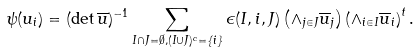<formula> <loc_0><loc_0><loc_500><loc_500>\psi ( u _ { i } ) = ( \det \overline { u } ) ^ { - 1 } \sum _ { I \cap J = \emptyset , ( I \cup J ) ^ { c } = \{ i \} } \epsilon ( I , i , J ) \left ( \wedge _ { j \in J } \overline { u } _ { j } \right ) \left ( \wedge _ { i \in I } \overline { u } _ { i } \right ) ^ { t } .</formula> 